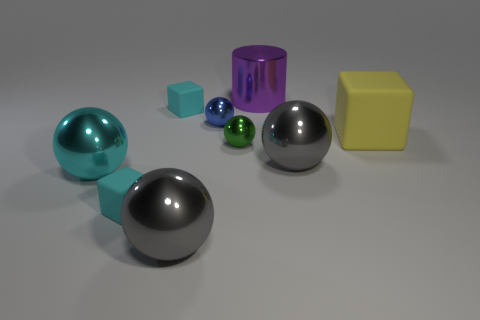Subtract all blue balls. How many balls are left? 4 Subtract 2 spheres. How many spheres are left? 3 Subtract all red balls. Subtract all green cylinders. How many balls are left? 5 Subtract all blocks. How many objects are left? 6 Subtract all large yellow objects. Subtract all big gray metal things. How many objects are left? 6 Add 9 large purple cylinders. How many large purple cylinders are left? 10 Add 9 small green balls. How many small green balls exist? 10 Subtract 0 cyan cylinders. How many objects are left? 9 